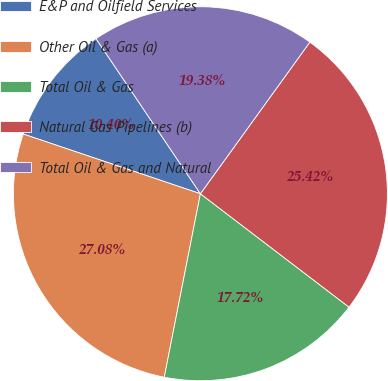Convert chart to OTSL. <chart><loc_0><loc_0><loc_500><loc_500><pie_chart><fcel>E&P and Oilfield Services<fcel>Other Oil & Gas (a)<fcel>Total Oil & Gas<fcel>Natural Gas Pipelines (b)<fcel>Total Oil & Gas and Natural<nl><fcel>10.4%<fcel>27.08%<fcel>17.72%<fcel>25.42%<fcel>19.38%<nl></chart> 